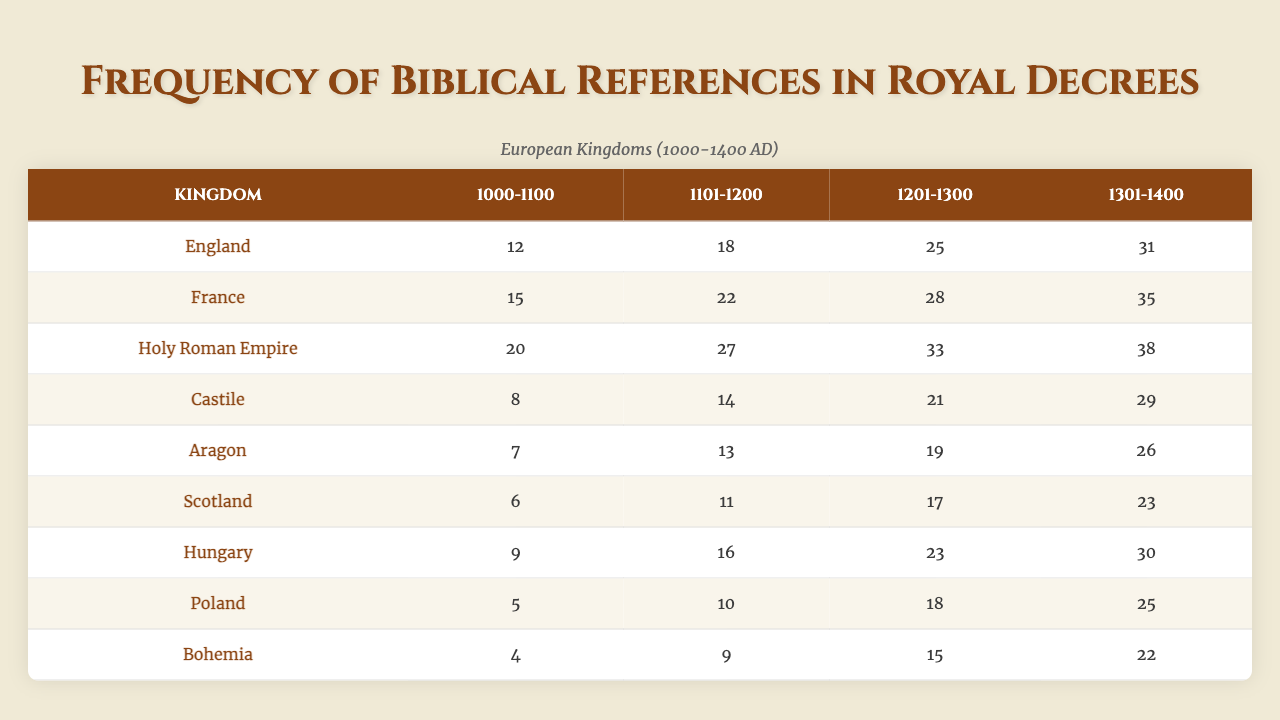What is the total number of biblical references in royal decrees from England between 1000 and 1100? The table shows that England had 12 biblical references from 1000 to 1100.
Answer: 12 Which kingdom had the highest number of biblical references in the time period 1301-1400? Looking at the table for the time period 1301-1400, the Holy Roman Empire had 38 biblical references, which is the highest among all listed kingdoms.
Answer: Holy Roman Empire What was the increase in the number of biblical references in France from 1201-1300 to 1301-1400? The number of biblical references in France for 1201-1300 is 28, and for 1301-1400 is 35. The increase is calculated as 35 - 28 = 7.
Answer: 7 In total, how many biblical references were recorded for Poland from 1000-1400? Adding the references from the table: 5 (1000-1100) + 10 (1101-1200) + 18 (1201-1300) + 25 (1301-1400) = 58.
Answer: 58 Is it true that Aragon had more biblical references than Castile in the time period 1201-1300? The table shows that Aragon had 19 biblical references and Castile had 21 references during that period, making the statement false.
Answer: No Which kingdom showed the smallest increase in biblical references from the period 1000-1100 to 1301-1400? By comparing the increases: England (31 - 12 = 19), France (35 - 15 = 20), Holy Roman Empire (38 - 20 = 18), Castile (29 - 8 = 21), Aragon (26 - 7 = 19), Scotland (23 - 6 = 17), Hungary (30 - 9 = 21), Poland (25 - 5 = 20), Bohemia (22 - 4 = 18). Scotland had the smallest increase of 17.
Answer: Scotland What is the average number of biblical references for Hungary between 1101-1200? Hungary had 16 biblical references between 1101-1200. Since there is only one value, the average is also 16.
Answer: 16 Which two kingdoms have the same number of biblical references in the period 1101-1200? In the table, both Hungary and Castile have 16 biblical references for that period, making them equal.
Answer: Hungary and Castile Calculate the total number of biblical references for all kingdoms during the time period 1301-1400. Summing the references: 31 (England) + 35 (France) + 38 (Holy Roman Empire) + 29 (Castile) + 26 (Aragon) + 23 (Scotland) + 30 (Hungary) + 25 (Poland) + 22 (Bohemia) gives a total of  29 + 30 + 31 + 22 + 35 + 38 = 299.
Answer: 299 Did biblical references increase in all kingdoms from 1000-1100 to 1301-1400? Examining the table, we see that all kingdoms show an increase in biblical references from the 1000-1100 to the 1301-1400 period. Therefore, the answer is yes.
Answer: Yes 